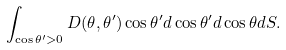Convert formula to latex. <formula><loc_0><loc_0><loc_500><loc_500>\int _ { \cos \theta ^ { \prime } > 0 } D ( \theta , \theta ^ { \prime } ) \cos \theta ^ { \prime } d \cos \theta ^ { \prime } d \cos \theta d S .</formula> 